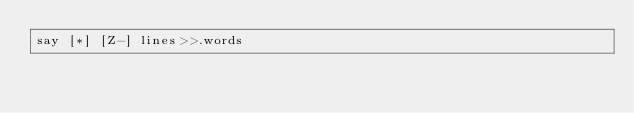<code> <loc_0><loc_0><loc_500><loc_500><_Perl_>say [*] [Z-] lines>>.words</code> 